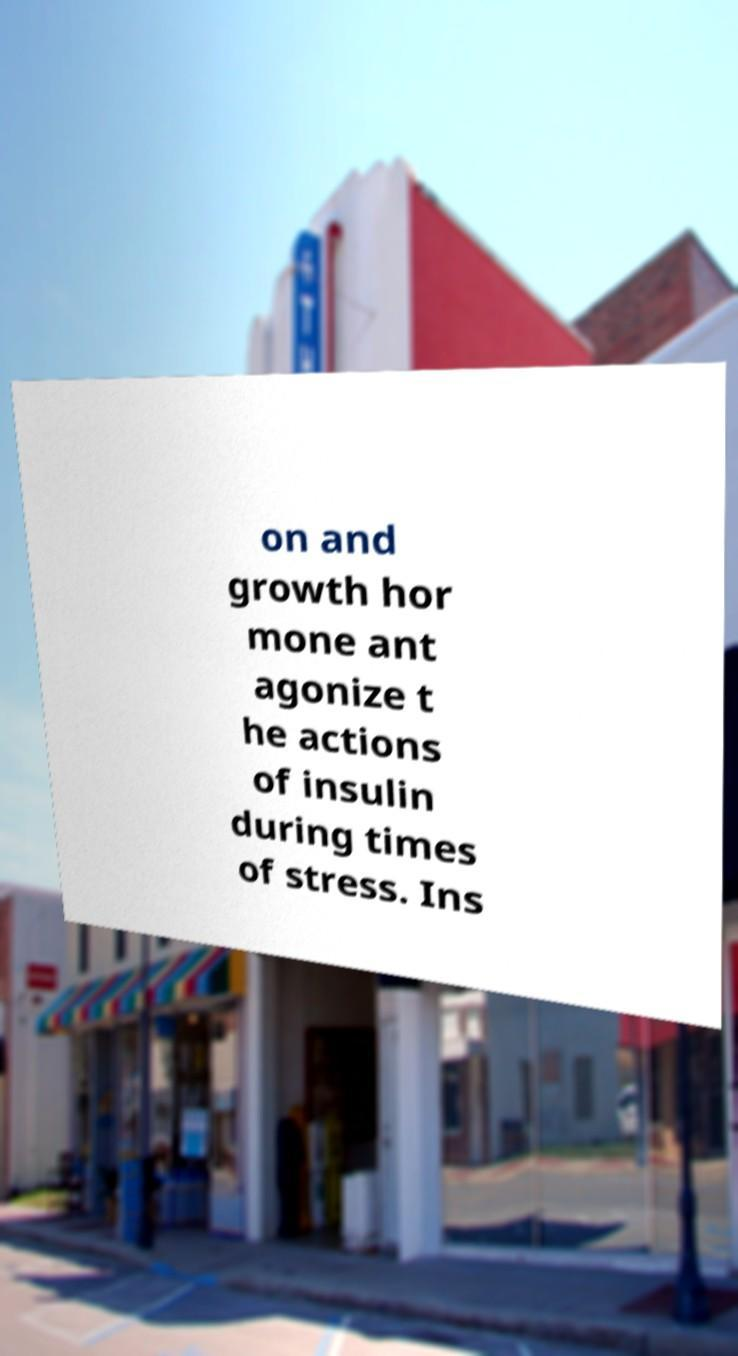What messages or text are displayed in this image? I need them in a readable, typed format. on and growth hor mone ant agonize t he actions of insulin during times of stress. Ins 